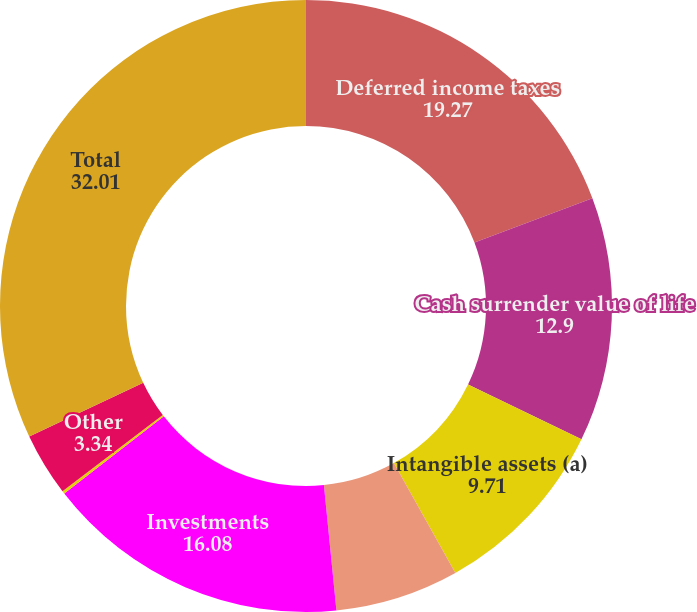Convert chart. <chart><loc_0><loc_0><loc_500><loc_500><pie_chart><fcel>Deferred income taxes<fcel>Cash surrender value of life<fcel>Intangible assets (a)<fcel>Project related long-term<fcel>Investments<fcel>Notes receivable<fcel>Other<fcel>Total<nl><fcel>19.27%<fcel>12.9%<fcel>9.71%<fcel>6.53%<fcel>16.08%<fcel>0.15%<fcel>3.34%<fcel>32.01%<nl></chart> 